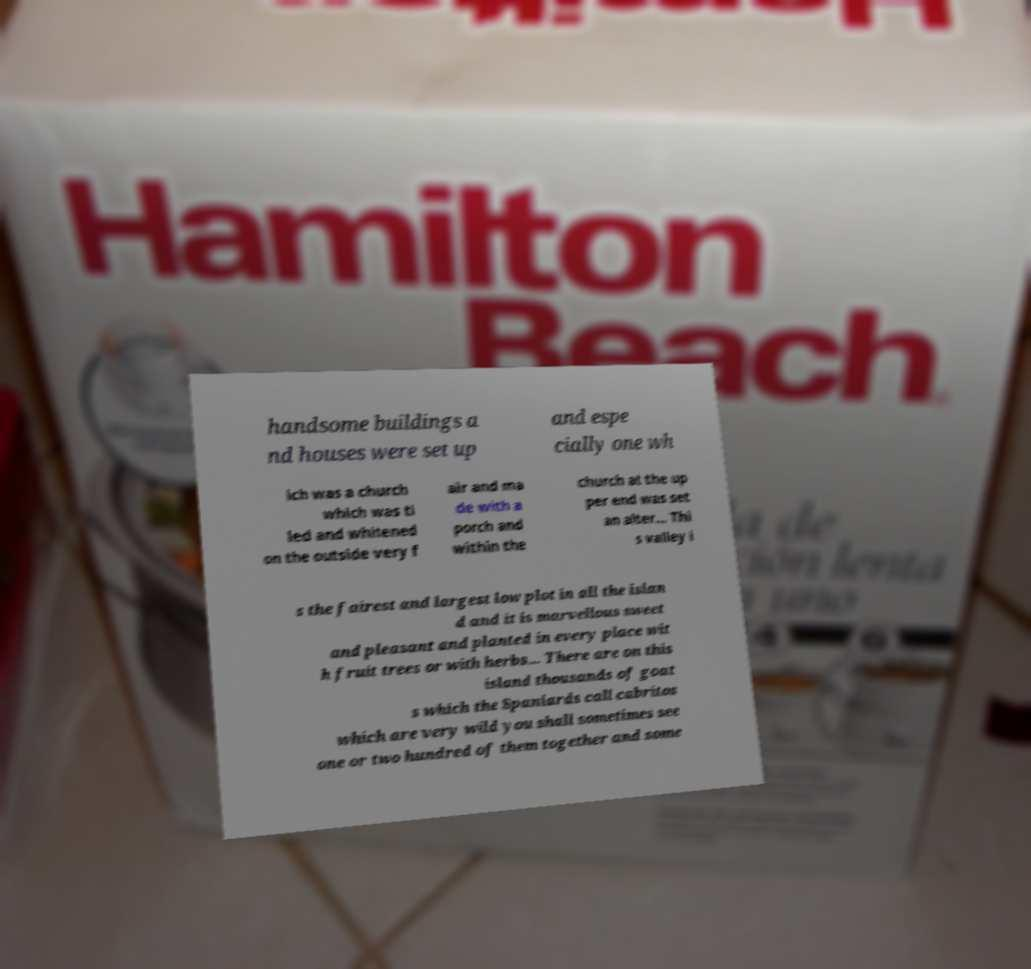I need the written content from this picture converted into text. Can you do that? handsome buildings a nd houses were set up and espe cially one wh ich was a church which was ti led and whitened on the outside very f air and ma de with a porch and within the church at the up per end was set an alter... Thi s valley i s the fairest and largest low plot in all the islan d and it is marvellous sweet and pleasant and planted in every place wit h fruit trees or with herbs... There are on this island thousands of goat s which the Spaniards call cabritos which are very wild you shall sometimes see one or two hundred of them together and some 